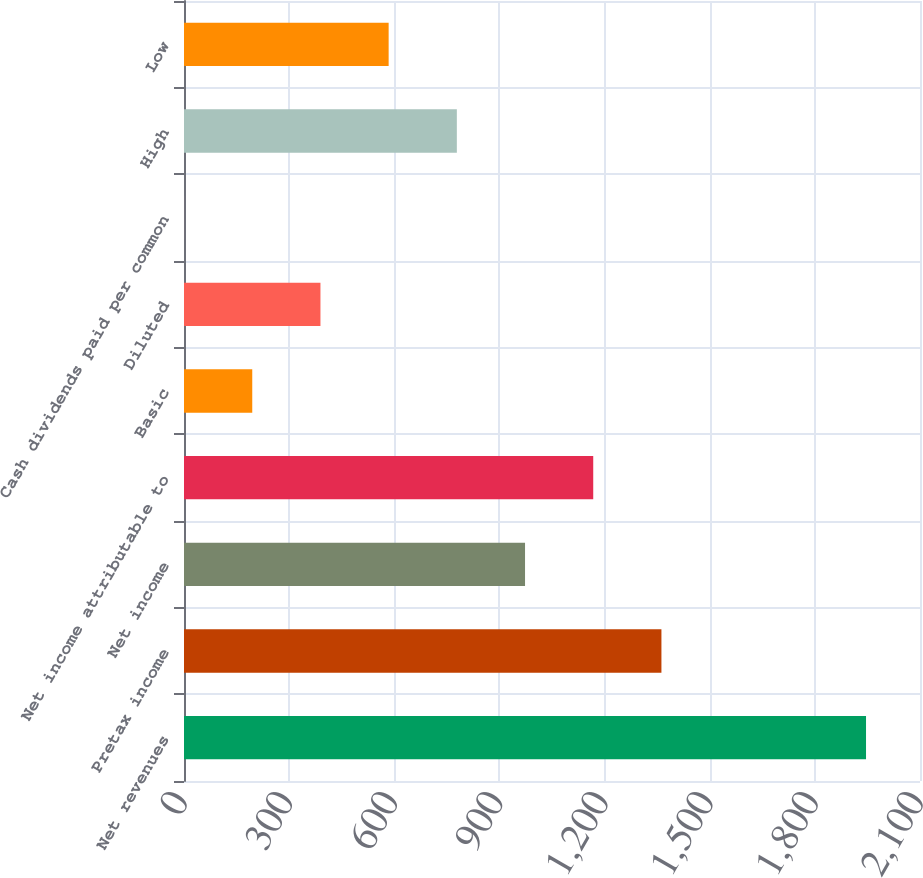Convert chart to OTSL. <chart><loc_0><loc_0><loc_500><loc_500><bar_chart><fcel>Net revenues<fcel>Pretax income<fcel>Net income<fcel>Net income attributable to<fcel>Basic<fcel>Diluted<fcel>Cash dividends paid per common<fcel>High<fcel>Low<nl><fcel>1946<fcel>1362.23<fcel>973.07<fcel>1167.65<fcel>194.75<fcel>389.33<fcel>0.17<fcel>778.49<fcel>583.91<nl></chart> 